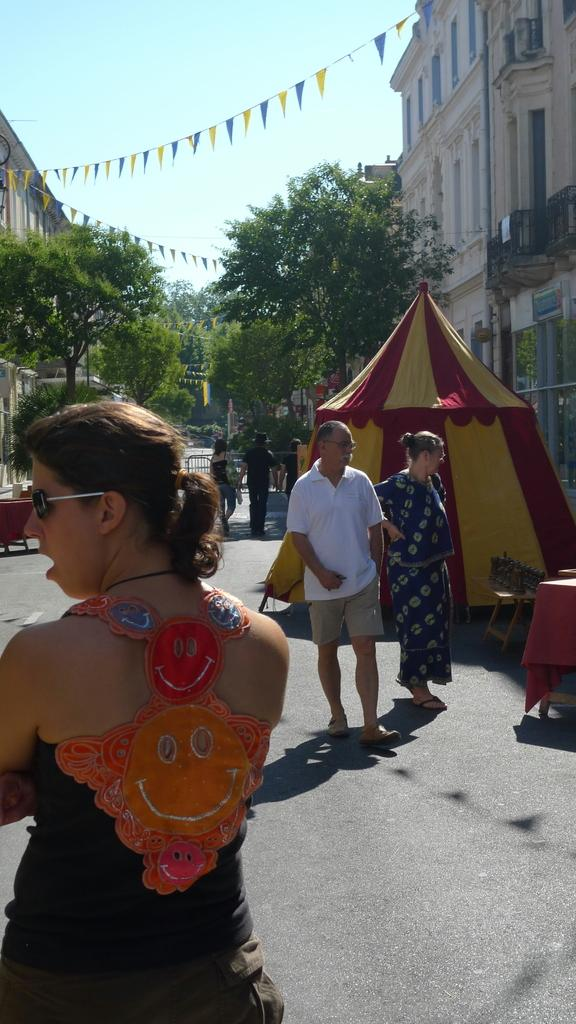What are the people in the image doing? The people in the image are walking down the street. What structures are present on the street? There are tents on the street. What type of vegetation can be seen on either side of the street? There are trees on either side of the street. What type of buildings can be seen on either side of the street? There are buildings on either side of the street. Can you tell me how many geese are walking down the street in the image? There are no geese present in the image; it features people walking down the street. What statement is being made by the people in the image? The image does not convey a specific statement; it simply shows people walking down the street. 